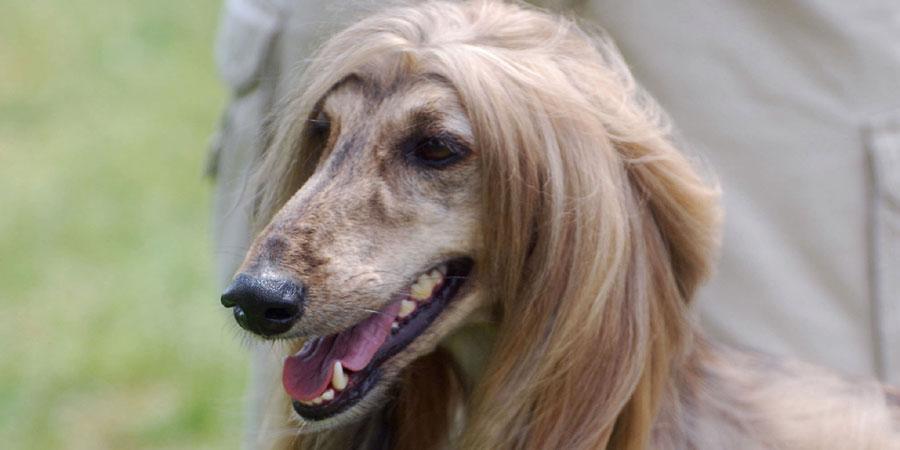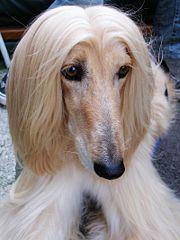The first image is the image on the left, the second image is the image on the right. Assess this claim about the two images: "At least one image shows a hound on all fours on the grassy ground.". Correct or not? Answer yes or no. No. 